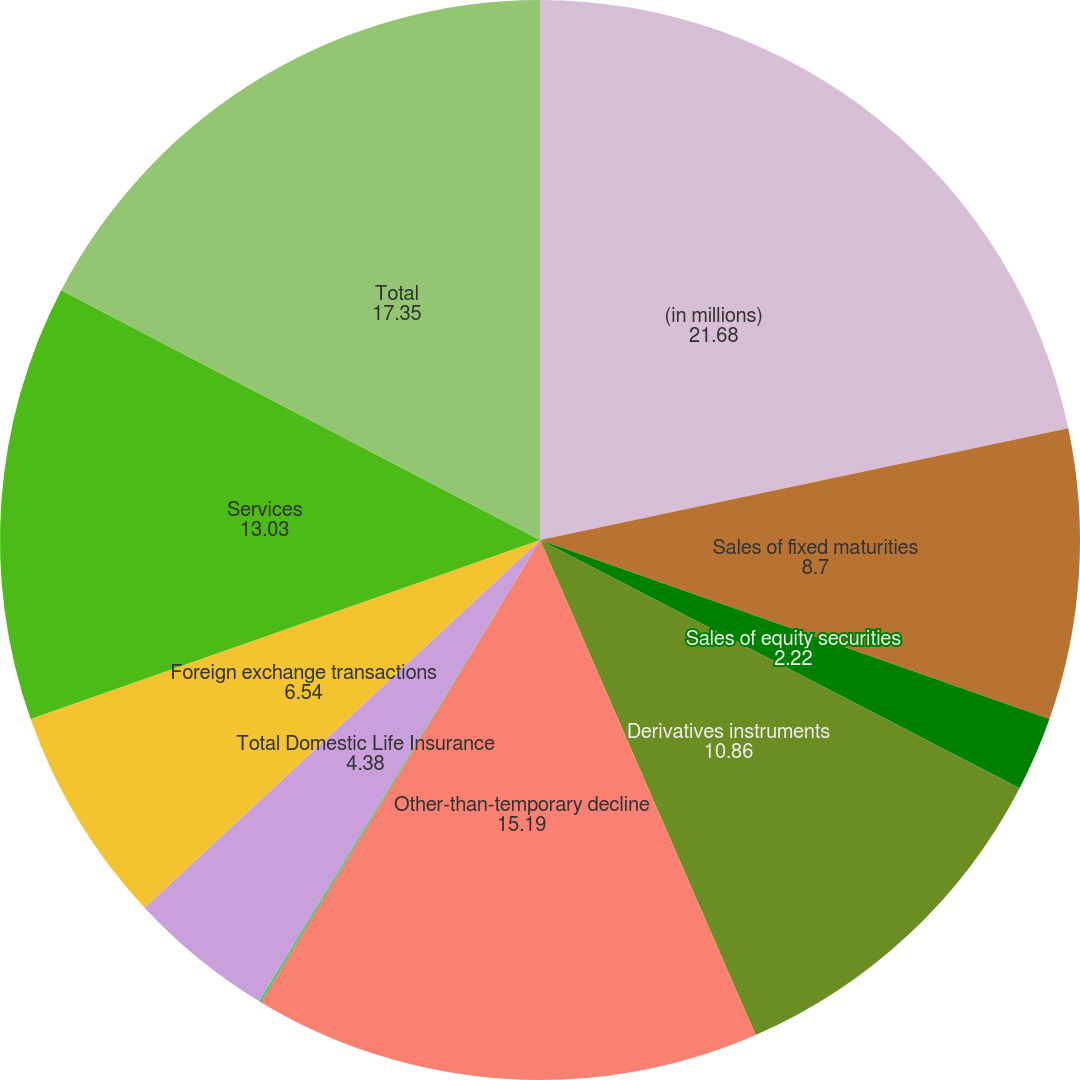<chart> <loc_0><loc_0><loc_500><loc_500><pie_chart><fcel>(in millions)<fcel>Sales of fixed maturities<fcel>Sales of equity securities<fcel>Derivatives instruments<fcel>Other-than-temporary decline<fcel>Other<fcel>Total Domestic Life Insurance<fcel>Foreign exchange transactions<fcel>Services<fcel>Total<nl><fcel>21.68%<fcel>8.7%<fcel>2.22%<fcel>10.86%<fcel>15.19%<fcel>0.05%<fcel>4.38%<fcel>6.54%<fcel>13.03%<fcel>17.35%<nl></chart> 